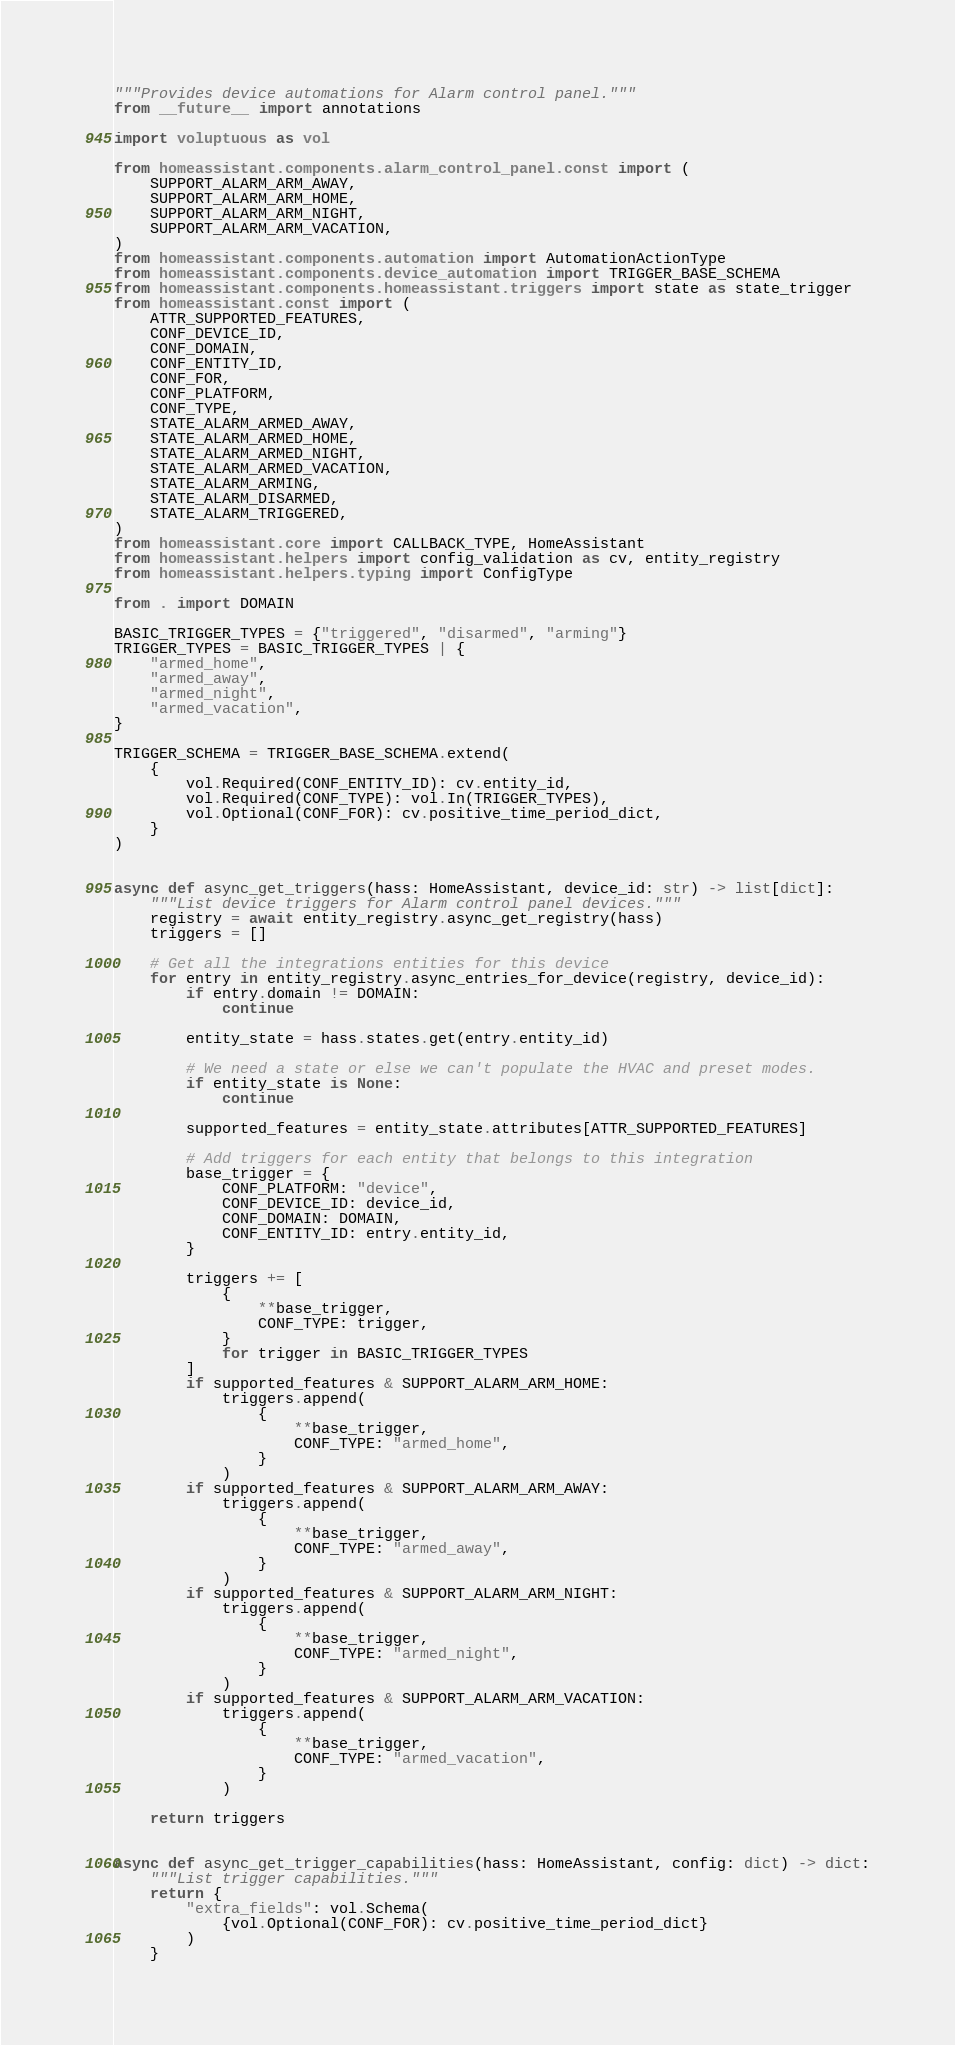<code> <loc_0><loc_0><loc_500><loc_500><_Python_>"""Provides device automations for Alarm control panel."""
from __future__ import annotations

import voluptuous as vol

from homeassistant.components.alarm_control_panel.const import (
    SUPPORT_ALARM_ARM_AWAY,
    SUPPORT_ALARM_ARM_HOME,
    SUPPORT_ALARM_ARM_NIGHT,
    SUPPORT_ALARM_ARM_VACATION,
)
from homeassistant.components.automation import AutomationActionType
from homeassistant.components.device_automation import TRIGGER_BASE_SCHEMA
from homeassistant.components.homeassistant.triggers import state as state_trigger
from homeassistant.const import (
    ATTR_SUPPORTED_FEATURES,
    CONF_DEVICE_ID,
    CONF_DOMAIN,
    CONF_ENTITY_ID,
    CONF_FOR,
    CONF_PLATFORM,
    CONF_TYPE,
    STATE_ALARM_ARMED_AWAY,
    STATE_ALARM_ARMED_HOME,
    STATE_ALARM_ARMED_NIGHT,
    STATE_ALARM_ARMED_VACATION,
    STATE_ALARM_ARMING,
    STATE_ALARM_DISARMED,
    STATE_ALARM_TRIGGERED,
)
from homeassistant.core import CALLBACK_TYPE, HomeAssistant
from homeassistant.helpers import config_validation as cv, entity_registry
from homeassistant.helpers.typing import ConfigType

from . import DOMAIN

BASIC_TRIGGER_TYPES = {"triggered", "disarmed", "arming"}
TRIGGER_TYPES = BASIC_TRIGGER_TYPES | {
    "armed_home",
    "armed_away",
    "armed_night",
    "armed_vacation",
}

TRIGGER_SCHEMA = TRIGGER_BASE_SCHEMA.extend(
    {
        vol.Required(CONF_ENTITY_ID): cv.entity_id,
        vol.Required(CONF_TYPE): vol.In(TRIGGER_TYPES),
        vol.Optional(CONF_FOR): cv.positive_time_period_dict,
    }
)


async def async_get_triggers(hass: HomeAssistant, device_id: str) -> list[dict]:
    """List device triggers for Alarm control panel devices."""
    registry = await entity_registry.async_get_registry(hass)
    triggers = []

    # Get all the integrations entities for this device
    for entry in entity_registry.async_entries_for_device(registry, device_id):
        if entry.domain != DOMAIN:
            continue

        entity_state = hass.states.get(entry.entity_id)

        # We need a state or else we can't populate the HVAC and preset modes.
        if entity_state is None:
            continue

        supported_features = entity_state.attributes[ATTR_SUPPORTED_FEATURES]

        # Add triggers for each entity that belongs to this integration
        base_trigger = {
            CONF_PLATFORM: "device",
            CONF_DEVICE_ID: device_id,
            CONF_DOMAIN: DOMAIN,
            CONF_ENTITY_ID: entry.entity_id,
        }

        triggers += [
            {
                **base_trigger,
                CONF_TYPE: trigger,
            }
            for trigger in BASIC_TRIGGER_TYPES
        ]
        if supported_features & SUPPORT_ALARM_ARM_HOME:
            triggers.append(
                {
                    **base_trigger,
                    CONF_TYPE: "armed_home",
                }
            )
        if supported_features & SUPPORT_ALARM_ARM_AWAY:
            triggers.append(
                {
                    **base_trigger,
                    CONF_TYPE: "armed_away",
                }
            )
        if supported_features & SUPPORT_ALARM_ARM_NIGHT:
            triggers.append(
                {
                    **base_trigger,
                    CONF_TYPE: "armed_night",
                }
            )
        if supported_features & SUPPORT_ALARM_ARM_VACATION:
            triggers.append(
                {
                    **base_trigger,
                    CONF_TYPE: "armed_vacation",
                }
            )

    return triggers


async def async_get_trigger_capabilities(hass: HomeAssistant, config: dict) -> dict:
    """List trigger capabilities."""
    return {
        "extra_fields": vol.Schema(
            {vol.Optional(CONF_FOR): cv.positive_time_period_dict}
        )
    }

</code> 